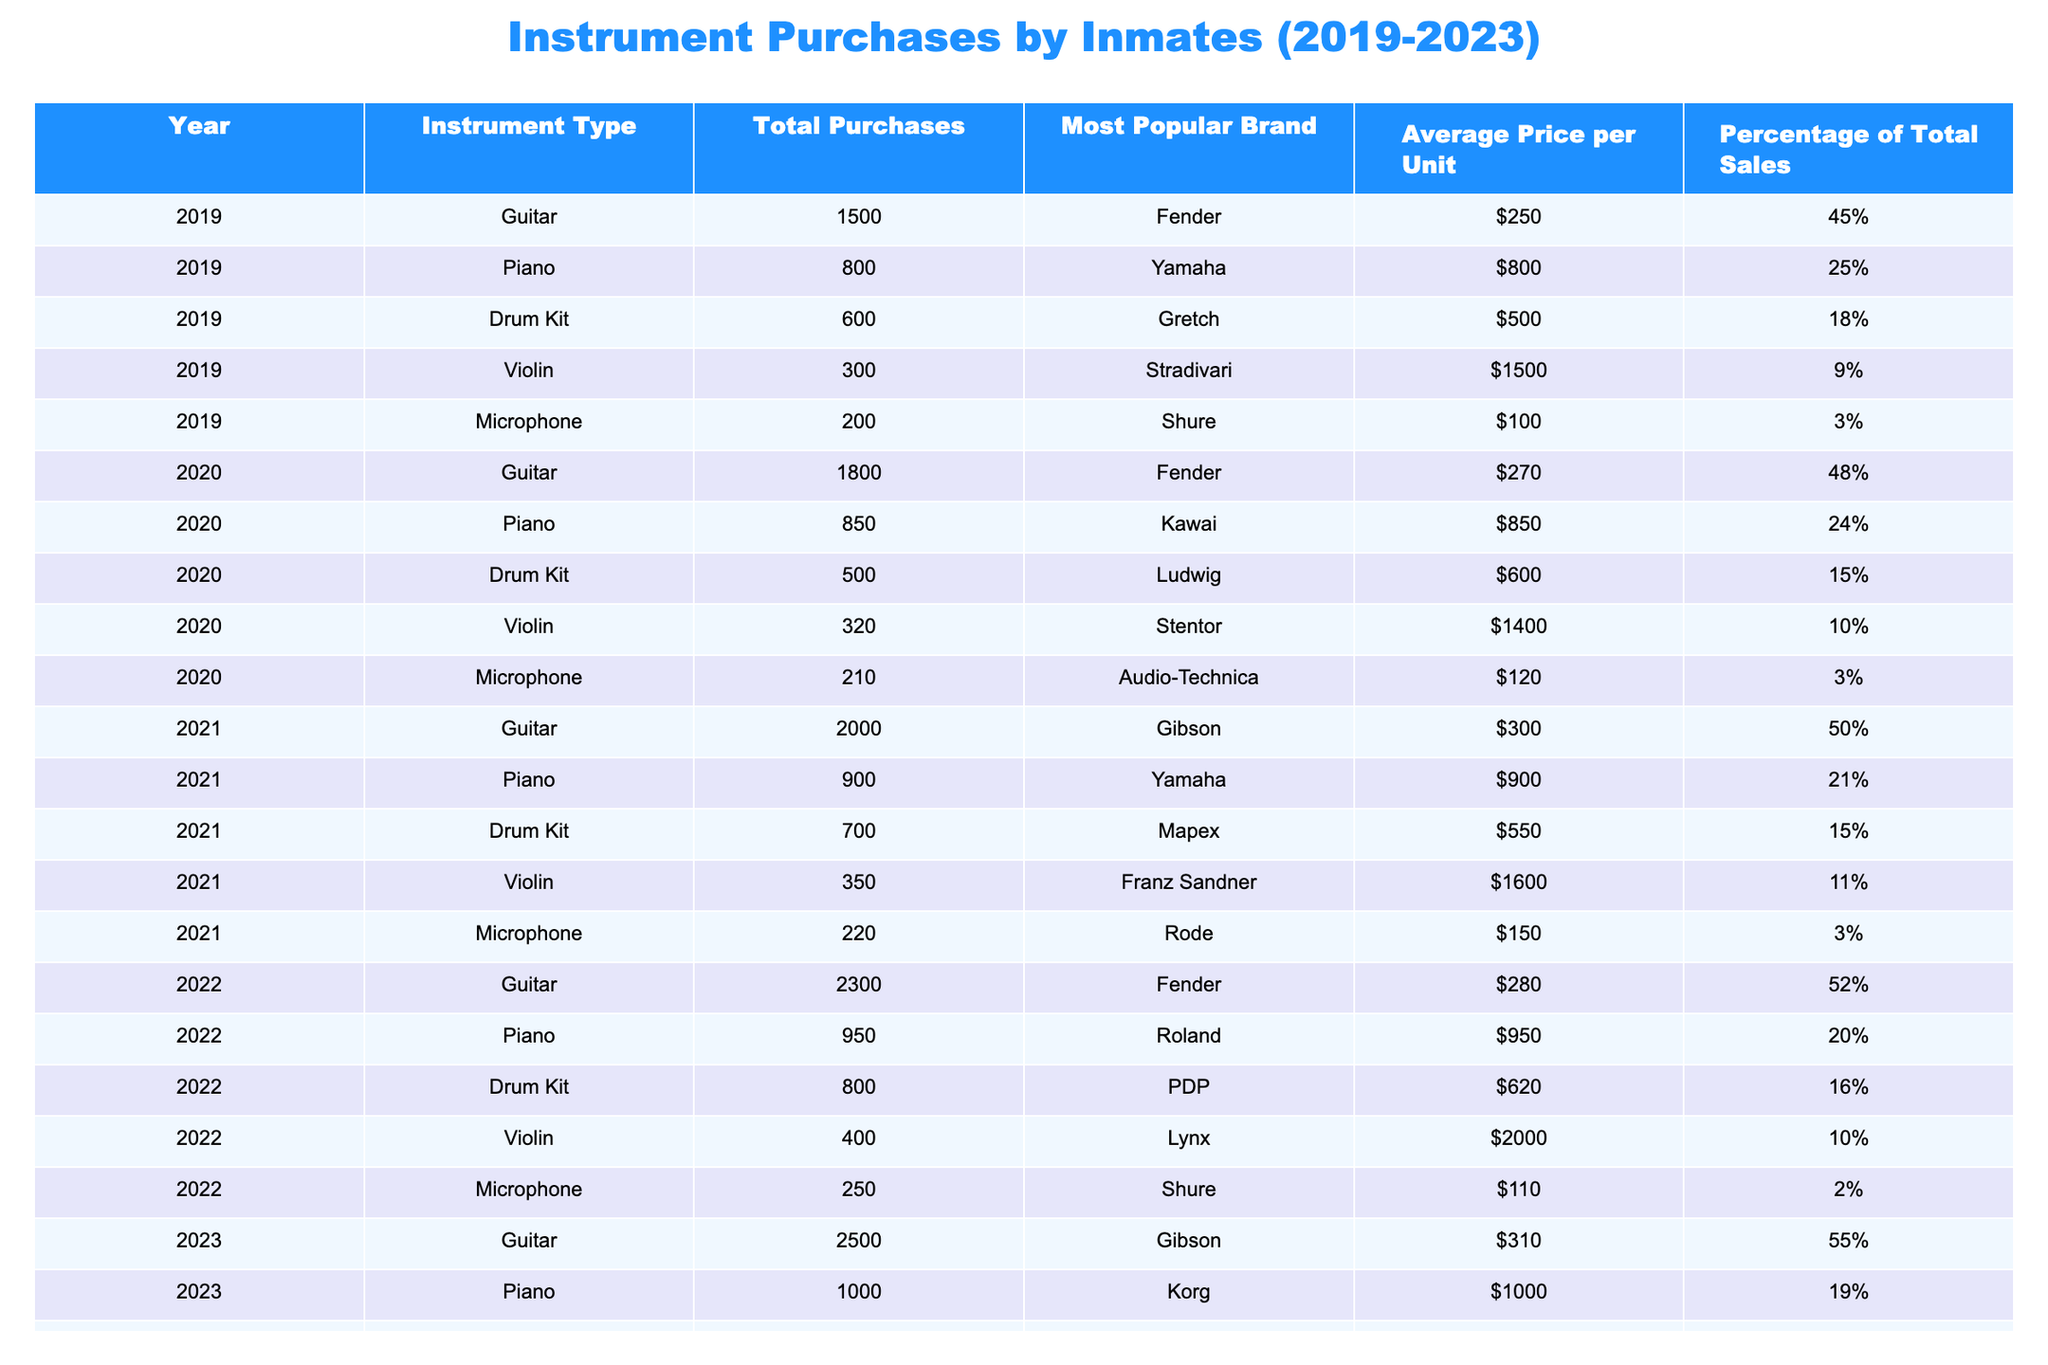What was the most popular instrument purchased in 2023? In 2023, the total purchases for Guitar were 2500, which is the highest among other instruments (Piano - 1000, Drum Kit - 900, Violin - 450, Microphone - 300).
Answer: Guitar Which brand was the most popular for Drum Kits in 2022? According to the table, the most popular brand for Drum Kits in 2022 was PDP, as indicated in the 'Most Popular Brand' column for that year.
Answer: PDP How much did the average price of Violins increase from 2019 to 2023? The average price of Violins in 2019 was $1500, and in 2023 it was $1800. The increase is calculated as $1800 - $1500 = $300.
Answer: $300 In which year did the total purchases of Pianos exceed 900? Looking at the total purchases for Pianos, the years where purchases exceeded 900 are 2021 (900), 2022 (950), and 2023 (1000), with purchases of 900 starting from 2021.
Answer: 2022 and 2023 What was the combined total number of Guitars and Pianos purchased in 2020? The total number of Guitars purchased in 2020 was 1800 and for Pianos, it was 850. Adding them together gives 1800 + 850 = 2650.
Answer: 2650 Did the purchases of Microphones make up more than 3% of total sales in any of the years? The table shows that Microphones made up 3% of total sales in both 2019, 2020, and significantly less (2%) in 2022 and 2023. Thus, it did not exceed 3% in any of the years post-2020.
Answer: No What was the overall trend in Guitar purchases over the years from 2019 to 2023? The table shows that Guitar purchases increased consistently each year: 1500 (2019), 1800 (2020), 2000 (2021), 2300 (2022), and 2500 (2023). This indicates a steady upward trend in purchases.
Answer: Increasing trend Which instrument had the least purchases in 2021 and what were the total figures? In 2021, the least purchased instrument was the Microphone with a total of 220 purchases, as shown in the 'Total Purchases' column.
Answer: Microphone, 220 How did the average price of Pianos in 2022 compare to that of 2023? The average price of Pianos in 2022 was $950 and in 2023 it was $1000. The difference is $1000 - $950 = $50.
Answer: Increased by $50 What percentage of total sales did Drum Kits represent in 2019? The table indicates that Drum Kits represented 18% of the total sales in 2019, as listed in the 'Percentage of Total Sales' column for that year.
Answer: 18% 